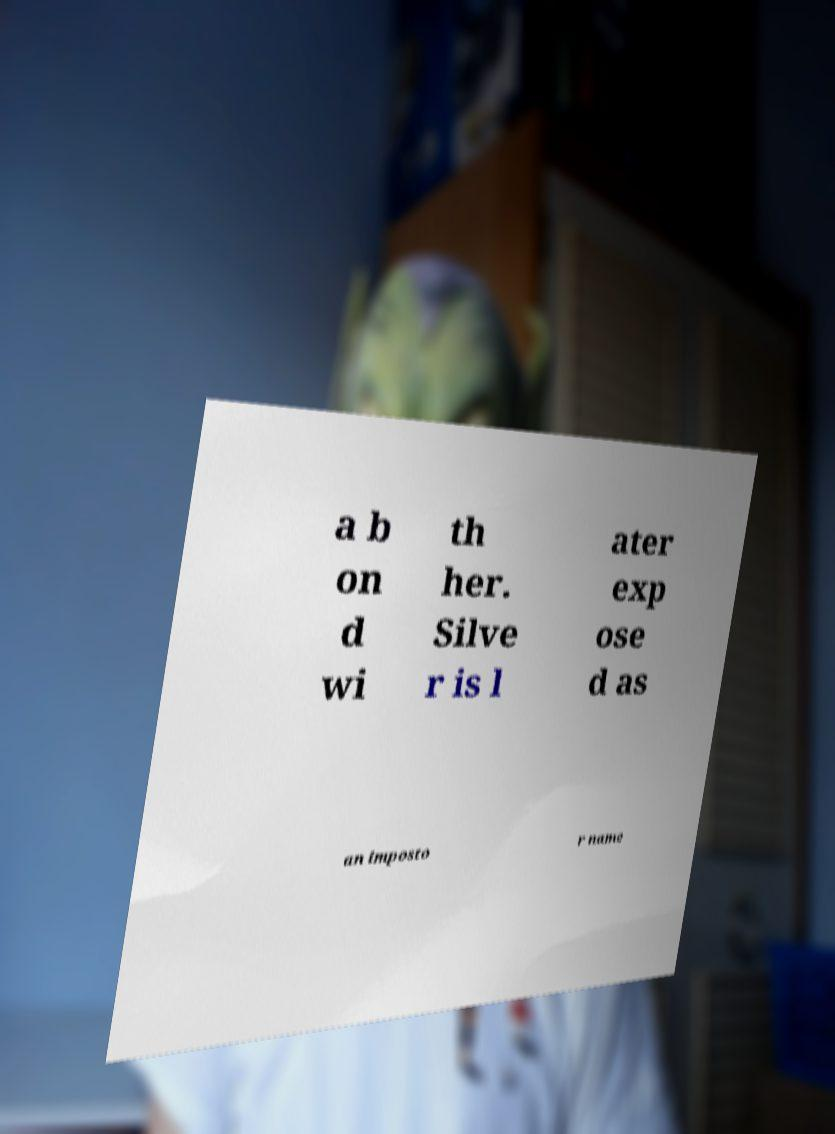Can you read and provide the text displayed in the image?This photo seems to have some interesting text. Can you extract and type it out for me? a b on d wi th her. Silve r is l ater exp ose d as an imposto r name 